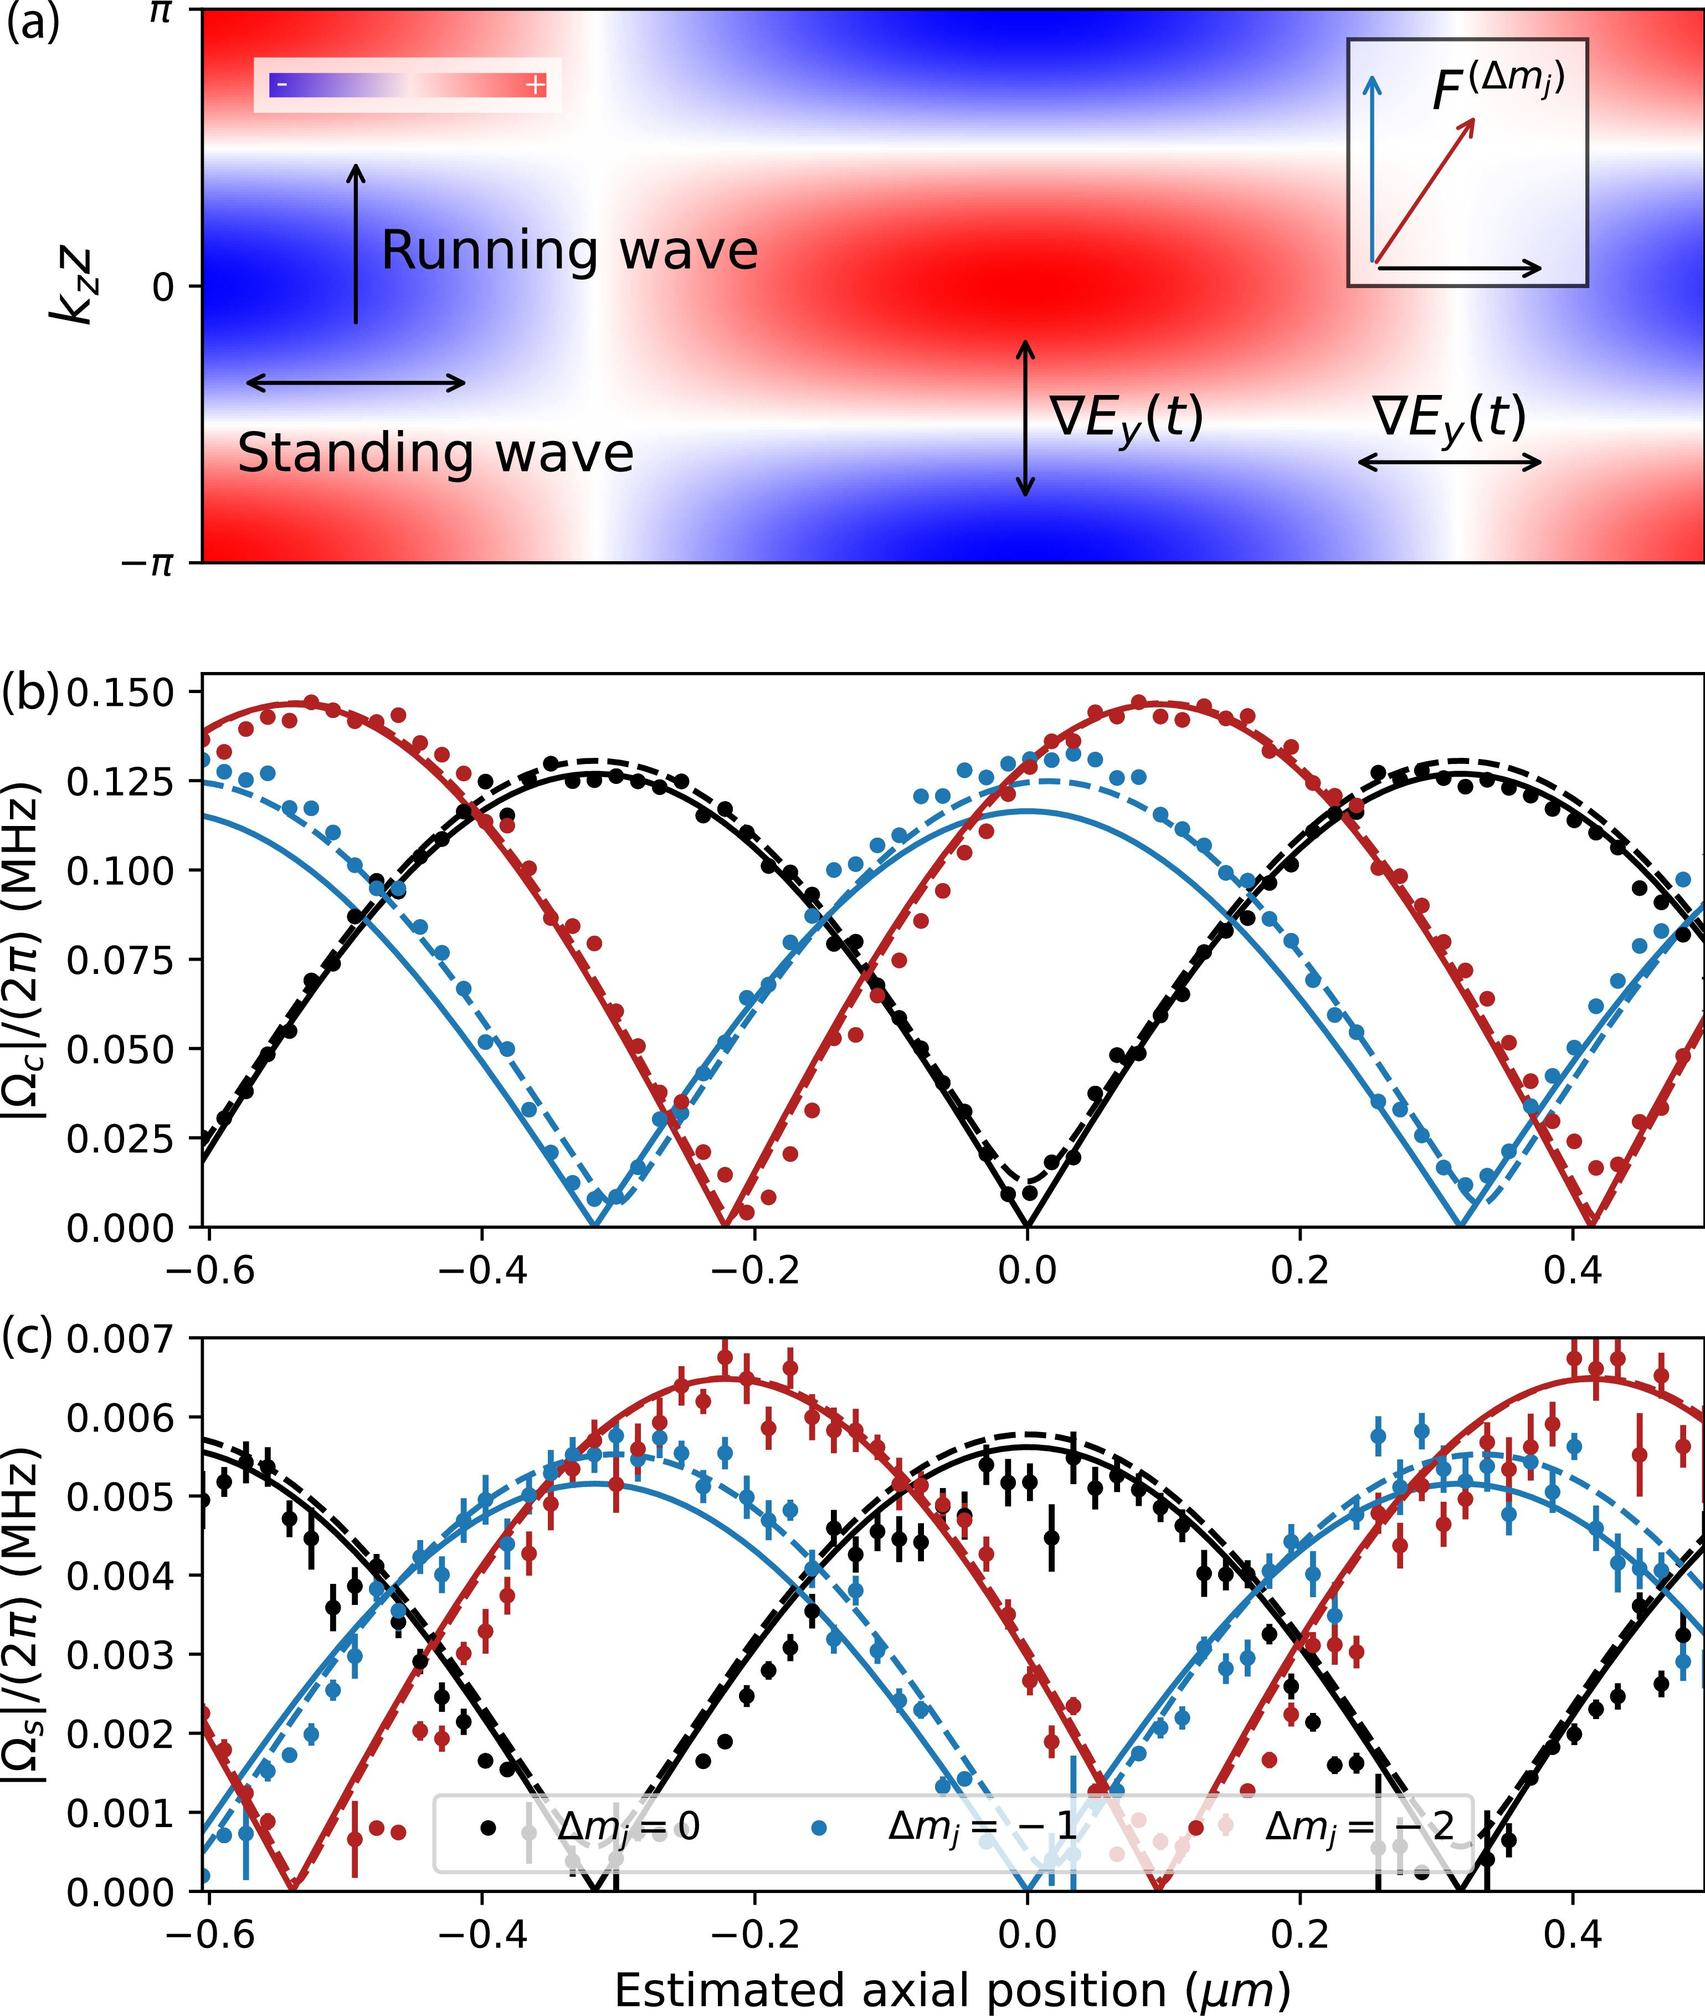Can you explain how the concept of standing and running waves is depicted in Figure (a)? Figure (a) illustrates the standing and running waves through a color gradient where the red and blue areas represent different wave phases. The arrows indicate directional movement, showing that standing waves appear stationary, marked by the up-and-down arrows, whereas running waves are indicated by left and right arrows, demonstrating their propagation along that direction.  What do these different waves imply about the forces acting in this scenario? The different wave types symbolize variations in how forces influence the medium's movement. Standing waves embody points of no net motion (nodes) suggesting balanced forces, whereas running waves indicate a net propagation direction implying that driving forces are dominating over restoring forces, leading to wave movement through the medium. 